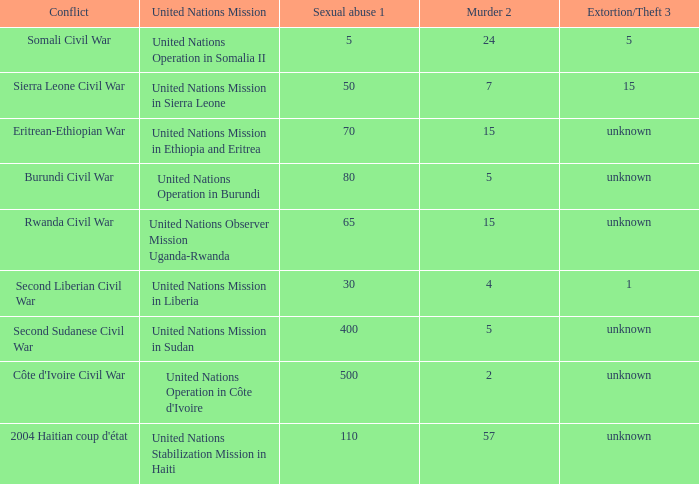What is the rate of sexual violence in the area affected by the burundi civil war? 80.0. 